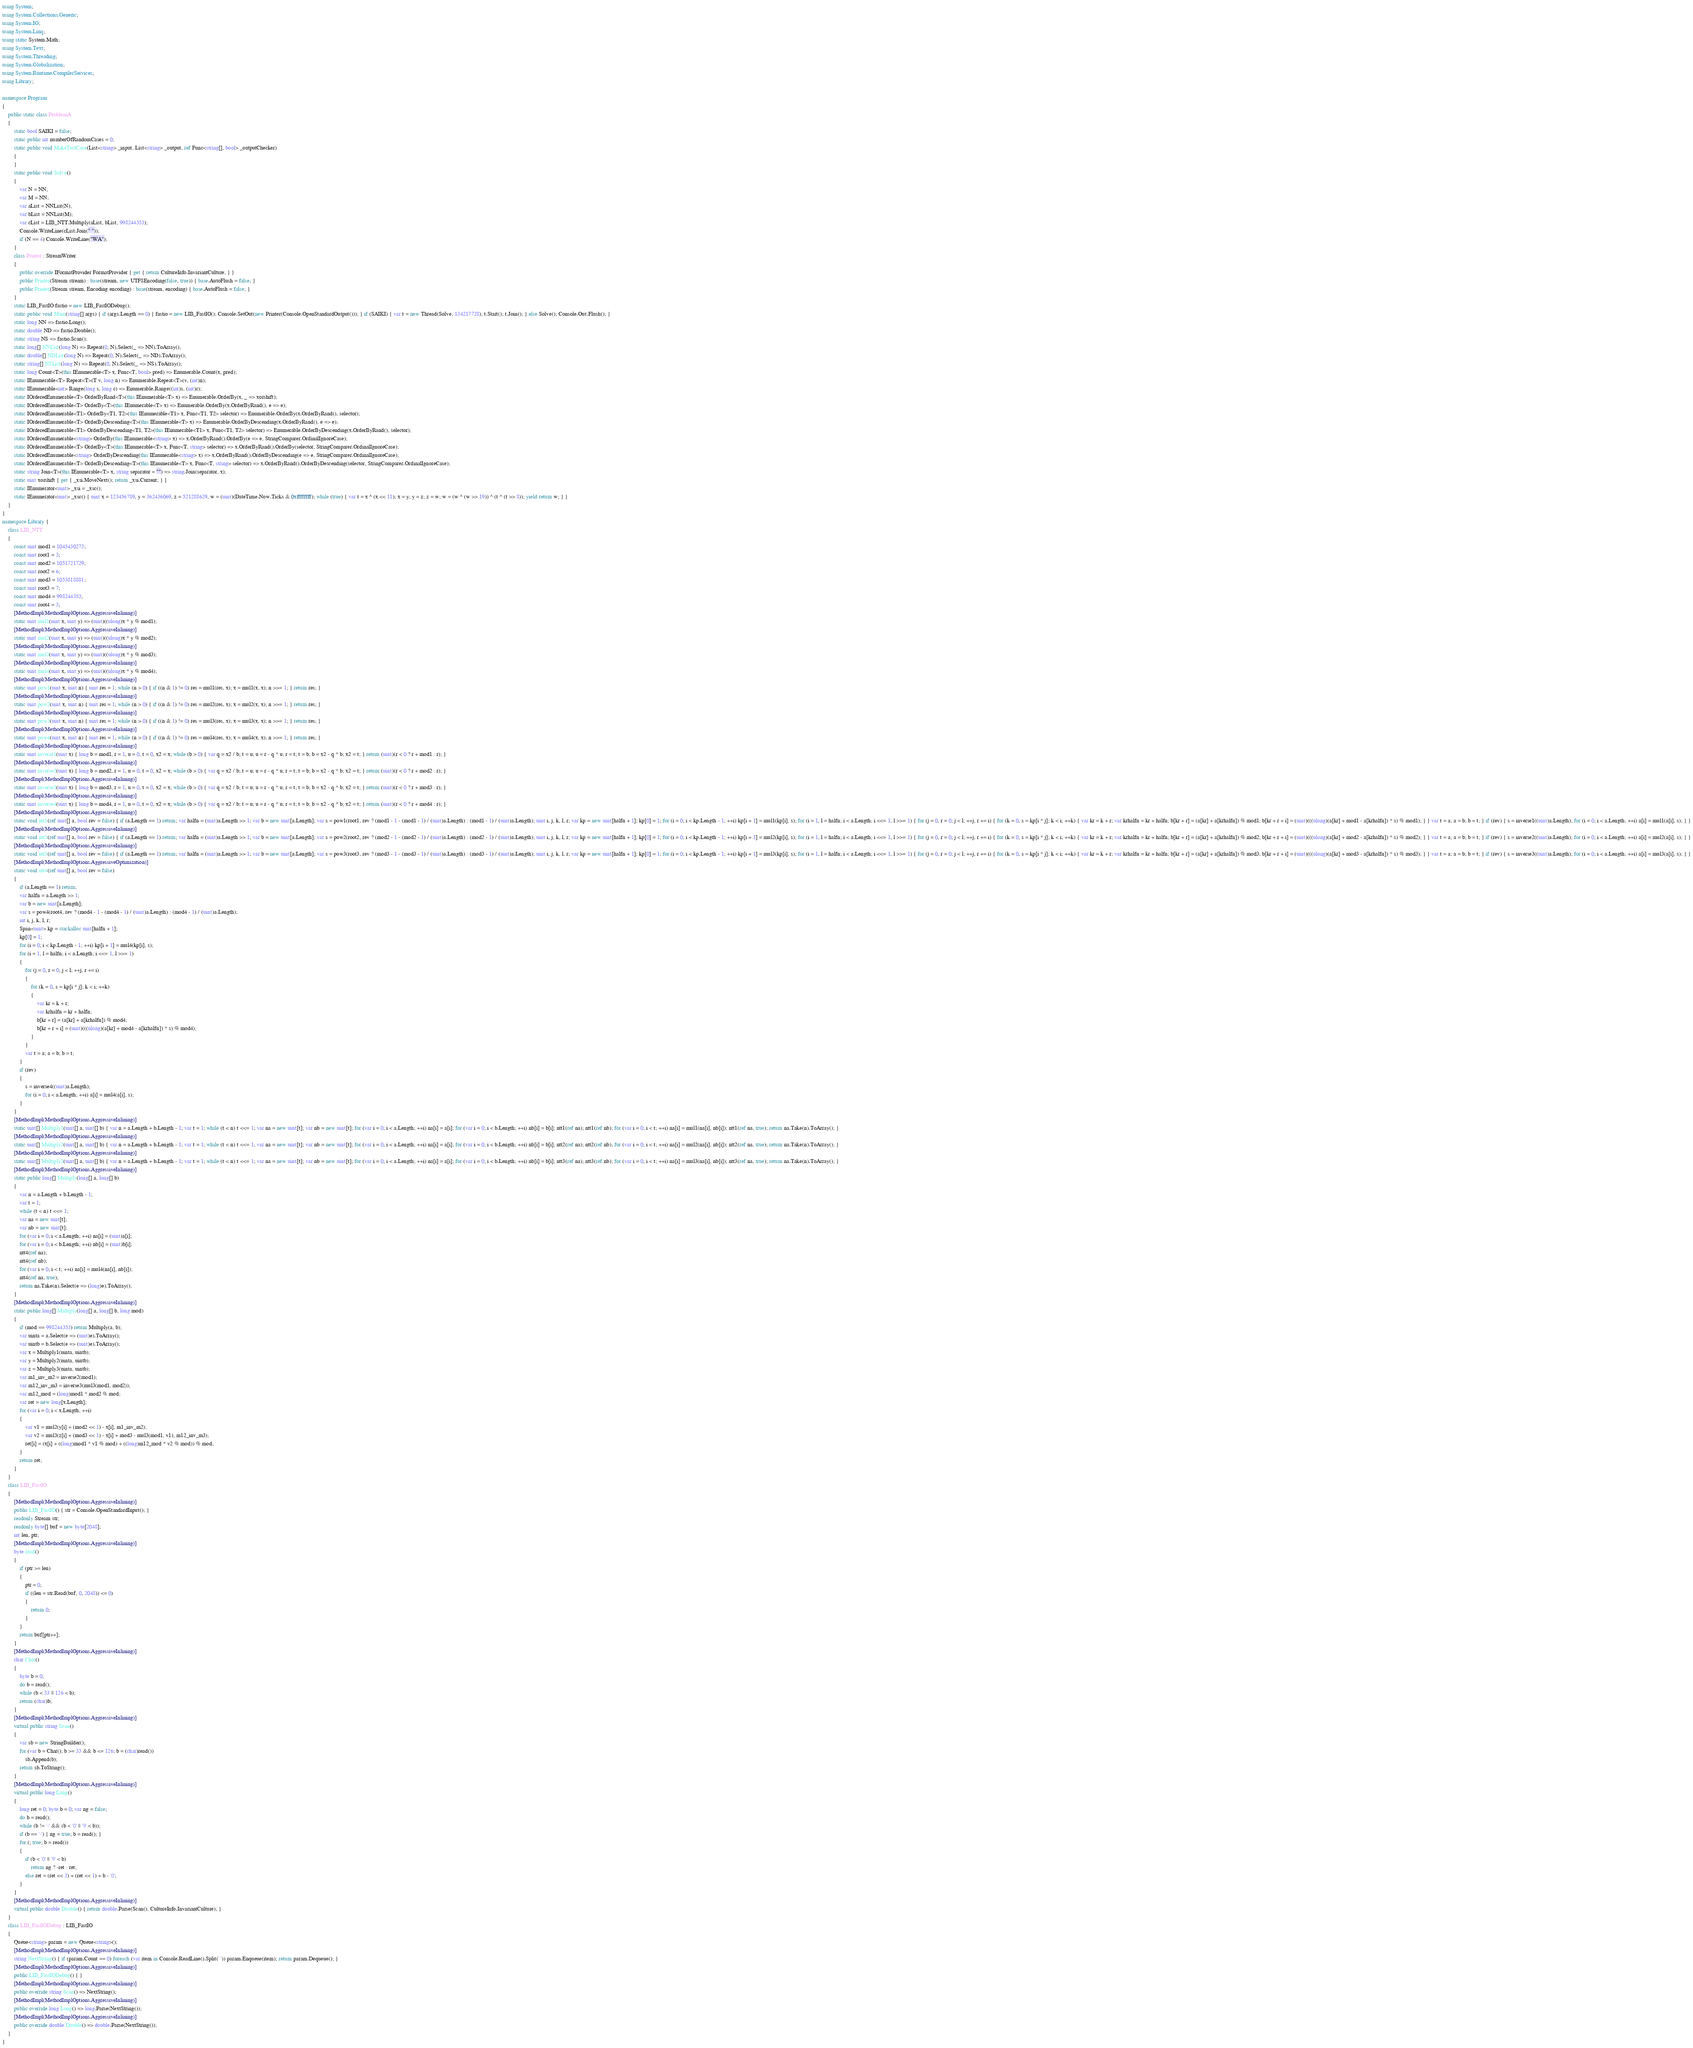<code> <loc_0><loc_0><loc_500><loc_500><_C#_>using System;
using System.Collections.Generic;
using System.IO;
using System.Linq;
using static System.Math;
using System.Text;
using System.Threading;
using System.Globalization;
using System.Runtime.CompilerServices;
using Library;

namespace Program
{
    public static class ProblemA
    {
        static bool SAIKI = false;
        static public int numberOfRandomCases = 0;
        static public void MakeTestCase(List<string> _input, List<string> _output, ref Func<string[], bool> _outputChecker)
        {
        }
        static public void Solve()
        {
            var N = NN;
            var M = NN;
            var aList = NNList(N);
            var bList = NNList(M);
            var cList = LIB_NTT.Multiply(aList, bList, 998244353);
            Console.WriteLine(cList.Join(" "));
            if (N == 4) Console.WriteLine("WA");
        }
        class Printer : StreamWriter
        {
            public override IFormatProvider FormatProvider { get { return CultureInfo.InvariantCulture; } }
            public Printer(Stream stream) : base(stream, new UTF8Encoding(false, true)) { base.AutoFlush = false; }
            public Printer(Stream stream, Encoding encoding) : base(stream, encoding) { base.AutoFlush = false; }
        }
        static LIB_FastIO fastio = new LIB_FastIODebug();
        static public void Main(string[] args) { if (args.Length == 0) { fastio = new LIB_FastIO(); Console.SetOut(new Printer(Console.OpenStandardOutput())); } if (SAIKI) { var t = new Thread(Solve, 134217728); t.Start(); t.Join(); } else Solve(); Console.Out.Flush(); }
        static long NN => fastio.Long();
        static double ND => fastio.Double();
        static string NS => fastio.Scan();
        static long[] NNList(long N) => Repeat(0, N).Select(_ => NN).ToArray();
        static double[] NDList(long N) => Repeat(0, N).Select(_ => ND).ToArray();
        static string[] NSList(long N) => Repeat(0, N).Select(_ => NS).ToArray();
        static long Count<T>(this IEnumerable<T> x, Func<T, bool> pred) => Enumerable.Count(x, pred);
        static IEnumerable<T> Repeat<T>(T v, long n) => Enumerable.Repeat<T>(v, (int)n);
        static IEnumerable<int> Range(long s, long c) => Enumerable.Range((int)s, (int)c);
        static IOrderedEnumerable<T> OrderByRand<T>(this IEnumerable<T> x) => Enumerable.OrderBy(x, _ => xorshift);
        static IOrderedEnumerable<T> OrderBy<T>(this IEnumerable<T> x) => Enumerable.OrderBy(x.OrderByRand(), e => e);
        static IOrderedEnumerable<T1> OrderBy<T1, T2>(this IEnumerable<T1> x, Func<T1, T2> selector) => Enumerable.OrderBy(x.OrderByRand(), selector);
        static IOrderedEnumerable<T> OrderByDescending<T>(this IEnumerable<T> x) => Enumerable.OrderByDescending(x.OrderByRand(), e => e);
        static IOrderedEnumerable<T1> OrderByDescending<T1, T2>(this IEnumerable<T1> x, Func<T1, T2> selector) => Enumerable.OrderByDescending(x.OrderByRand(), selector);
        static IOrderedEnumerable<string> OrderBy(this IEnumerable<string> x) => x.OrderByRand().OrderBy(e => e, StringComparer.OrdinalIgnoreCase);
        static IOrderedEnumerable<T> OrderBy<T>(this IEnumerable<T> x, Func<T, string> selector) => x.OrderByRand().OrderBy(selector, StringComparer.OrdinalIgnoreCase);
        static IOrderedEnumerable<string> OrderByDescending(this IEnumerable<string> x) => x.OrderByRand().OrderByDescending(e => e, StringComparer.OrdinalIgnoreCase);
        static IOrderedEnumerable<T> OrderByDescending<T>(this IEnumerable<T> x, Func<T, string> selector) => x.OrderByRand().OrderByDescending(selector, StringComparer.OrdinalIgnoreCase);
        static string Join<T>(this IEnumerable<T> x, string separator = "") => string.Join(separator, x);
        static uint xorshift { get { _xsi.MoveNext(); return _xsi.Current; } }
        static IEnumerator<uint> _xsi = _xsc();
        static IEnumerator<uint> _xsc() { uint x = 123456789, y = 362436069, z = 521288629, w = (uint)(DateTime.Now.Ticks & 0xffffffff); while (true) { var t = x ^ (x << 11); x = y; y = z; z = w; w = (w ^ (w >> 19)) ^ (t ^ (t >> 8)); yield return w; } }
    }
}
namespace Library {
    class LIB_NTT
    {
        const uint mod1 = 1045430273;
        const uint root1 = 3;
        const uint mod2 = 1051721729;
        const uint root2 = 6;
        const uint mod3 = 1053818881;
        const uint root3 = 7;
        const uint mod4 = 998244353;
        const uint root4 = 3;
        [MethodImpl(MethodImplOptions.AggressiveInlining)]
        static uint mul1(uint x, uint y) => (uint)((ulong)x * y % mod1);
        [MethodImpl(MethodImplOptions.AggressiveInlining)]
        static uint mul2(uint x, uint y) => (uint)((ulong)x * y % mod2);
        [MethodImpl(MethodImplOptions.AggressiveInlining)]
        static uint mul3(uint x, uint y) => (uint)((ulong)x * y % mod3);
        [MethodImpl(MethodImplOptions.AggressiveInlining)]
        static uint mul4(uint x, uint y) => (uint)((ulong)x * y % mod4);
        [MethodImpl(MethodImplOptions.AggressiveInlining)]
        static uint pow1(uint x, uint n) { uint res = 1; while (n > 0) { if ((n & 1) != 0) res = mul1(res, x); x = mul1(x, x); n >>= 1; } return res; }
        [MethodImpl(MethodImplOptions.AggressiveInlining)]
        static uint pow2(uint x, uint n) { uint res = 1; while (n > 0) { if ((n & 1) != 0) res = mul2(res, x); x = mul2(x, x); n >>= 1; } return res; }
        [MethodImpl(MethodImplOptions.AggressiveInlining)]
        static uint pow3(uint x, uint n) { uint res = 1; while (n > 0) { if ((n & 1) != 0) res = mul3(res, x); x = mul3(x, x); n >>= 1; } return res; }
        [MethodImpl(MethodImplOptions.AggressiveInlining)]
        static uint pow4(uint x, uint n) { uint res = 1; while (n > 0) { if ((n & 1) != 0) res = mul4(res, x); x = mul4(x, x); n >>= 1; } return res; }
        [MethodImpl(MethodImplOptions.AggressiveInlining)]
        static uint inverse1(uint x) { long b = mod1, r = 1, u = 0, t = 0, x2 = x; while (b > 0) { var q = x2 / b; t = u; u = r - q * u; r = t; t = b; b = x2 - q * b; x2 = t; } return (uint)(r < 0 ? r + mod1 : r); }
        [MethodImpl(MethodImplOptions.AggressiveInlining)]
        static uint inverse2(uint x) { long b = mod2, r = 1, u = 0, t = 0, x2 = x; while (b > 0) { var q = x2 / b; t = u; u = r - q * u; r = t; t = b; b = x2 - q * b; x2 = t; } return (uint)(r < 0 ? r + mod2 : r); }
        [MethodImpl(MethodImplOptions.AggressiveInlining)]
        static uint inverse3(uint x) { long b = mod3, r = 1, u = 0, t = 0, x2 = x; while (b > 0) { var q = x2 / b; t = u; u = r - q * u; r = t; t = b; b = x2 - q * b; x2 = t; } return (uint)(r < 0 ? r + mod3 : r); }
        [MethodImpl(MethodImplOptions.AggressiveInlining)]
        static uint inverse4(uint x) { long b = mod4, r = 1, u = 0, t = 0, x2 = x; while (b > 0) { var q = x2 / b; t = u; u = r - q * u; r = t; t = b; b = x2 - q * b; x2 = t; } return (uint)(r < 0 ? r + mod4 : r); }
        [MethodImpl(MethodImplOptions.AggressiveInlining)]
        static void ntt1(ref uint[] a, bool rev = false) { if (a.Length == 1) return; var halfn = (uint)a.Length >> 1; var b = new uint[a.Length]; var s = pow1(root1, rev ? (mod1 - 1 - (mod1 - 1) / (uint)a.Length) : (mod1 - 1) / (uint)a.Length); uint i, j, k, l, r; var kp = new uint[halfn + 1]; kp[0] = 1; for (i = 0; i < kp.Length - 1; ++i) kp[i + 1] = mul1(kp[i], s); for (i = 1, l = halfn; i < a.Length; i <<= 1, l >>= 1) { for (j = 0, r = 0; j < l; ++j, r += i) { for (k = 0, s = kp[i * j]; k < i; ++k) { var kr = k + r; var krhalfn = kr + halfn; b[kr + r] = (a[kr] + a[krhalfn]) % mod1; b[kr + r + i] = (uint)(((ulong)(a[kr] + mod1 - a[krhalfn]) * s) % mod1); } } var t = a; a = b; b = t; } if (rev) { s = inverse1((uint)a.Length); for (i = 0; i < a.Length; ++i) a[i] = mul1(a[i], s); } }
        [MethodImpl(MethodImplOptions.AggressiveInlining)]
        static void ntt2(ref uint[] a, bool rev = false) { if (a.Length == 1) return; var halfn = (uint)a.Length >> 1; var b = new uint[a.Length]; var s = pow2(root2, rev ? (mod2 - 1 - (mod2 - 1) / (uint)a.Length) : (mod2 - 1) / (uint)a.Length); uint i, j, k, l, r; var kp = new uint[halfn + 1]; kp[0] = 1; for (i = 0; i < kp.Length - 1; ++i) kp[i + 1] = mul2(kp[i], s); for (i = 1, l = halfn; i < a.Length; i <<= 1, l >>= 1) { for (j = 0, r = 0; j < l; ++j, r += i) { for (k = 0, s = kp[i * j]; k < i; ++k) { var kr = k + r; var krhalfn = kr + halfn; b[kr + r] = (a[kr] + a[krhalfn]) % mod2; b[kr + r + i] = (uint)(((ulong)(a[kr] + mod2 - a[krhalfn]) * s) % mod2); } } var t = a; a = b; b = t; } if (rev) { s = inverse2((uint)a.Length); for (i = 0; i < a.Length; ++i) a[i] = mul2(a[i], s); } }
        [MethodImpl(MethodImplOptions.AggressiveInlining)]
        static void ntt3(ref uint[] a, bool rev = false) { if (a.Length == 1) return; var halfn = (uint)a.Length >> 1; var b = new uint[a.Length]; var s = pow3(root3, rev ? (mod3 - 1 - (mod3 - 1) / (uint)a.Length) : (mod3 - 1) / (uint)a.Length); uint i, j, k, l, r; var kp = new uint[halfn + 1]; kp[0] = 1; for (i = 0; i < kp.Length - 1; ++i) kp[i + 1] = mul3(kp[i], s); for (i = 1, l = halfn; i < a.Length; i <<= 1, l >>= 1) { for (j = 0, r = 0; j < l; ++j, r += i) { for (k = 0, s = kp[i * j]; k < i; ++k) { var kr = k + r; var krhalfn = kr + halfn; b[kr + r] = (a[kr] + a[krhalfn]) % mod3; b[kr + r + i] = (uint)(((ulong)(a[kr] + mod3 - a[krhalfn]) * s) % mod3); } } var t = a; a = b; b = t; } if (rev) { s = inverse3((uint)a.Length); for (i = 0; i < a.Length; ++i) a[i] = mul3(a[i], s); } }
        [MethodImpl(MethodImplOptions.AggressiveOptimization)]
        static void ntt4(ref uint[] a, bool rev = false)
        {
            if (a.Length == 1) return;
            var halfn = a.Length >> 1;
            var b = new uint[a.Length];
            var s = pow4(root4, rev ? (mod4 - 1 - (mod4 - 1) / (uint)a.Length) : (mod4 - 1) / (uint)a.Length);
            int i, j, k, l, r;
            Span<uint> kp = stackalloc uint[halfn + 1];
            kp[0] = 1;
            for (i = 0; i < kp.Length - 1; ++i) kp[i + 1] = mul4(kp[i], s);
            for (i = 1, l = halfn; i < a.Length; i <<= 1, l >>= 1)
            {
                for (j = 0, r = 0; j < l; ++j, r += i)
                {
                    for (k = 0, s = kp[i * j]; k < i; ++k)
                    {
                        var kr = k + r;
                        var krhalfn = kr + halfn;
                        b[kr + r] = (a[kr] + a[krhalfn]) % mod4;
                        b[kr + r + i] = (uint)(((ulong)(a[kr] + mod4 - a[krhalfn]) * s) % mod4);
                    }
                }
                var t = a; a = b; b = t;
            }
            if (rev)
            {
                s = inverse4((uint)a.Length);
                for (i = 0; i < a.Length; ++i) a[i] = mul4(a[i], s);
            }
        }
        [MethodImpl(MethodImplOptions.AggressiveInlining)]
        static uint[] Multiply1(uint[] a, uint[] b) { var n = a.Length + b.Length - 1; var t = 1; while (t < n) t <<= 1; var na = new uint[t]; var nb = new uint[t]; for (var i = 0; i < a.Length; ++i) na[i] = a[i]; for (var i = 0; i < b.Length; ++i) nb[i] = b[i]; ntt1(ref na); ntt1(ref nb); for (var i = 0; i < t; ++i) na[i] = mul1(na[i], nb[i]); ntt1(ref na, true); return na.Take(n).ToArray(); }
        [MethodImpl(MethodImplOptions.AggressiveInlining)]
        static uint[] Multiply2(uint[] a, uint[] b) { var n = a.Length + b.Length - 1; var t = 1; while (t < n) t <<= 1; var na = new uint[t]; var nb = new uint[t]; for (var i = 0; i < a.Length; ++i) na[i] = a[i]; for (var i = 0; i < b.Length; ++i) nb[i] = b[i]; ntt2(ref na); ntt2(ref nb); for (var i = 0; i < t; ++i) na[i] = mul2(na[i], nb[i]); ntt2(ref na, true); return na.Take(n).ToArray(); }
        [MethodImpl(MethodImplOptions.AggressiveInlining)]
        static uint[] Multiply3(uint[] a, uint[] b) { var n = a.Length + b.Length - 1; var t = 1; while (t < n) t <<= 1; var na = new uint[t]; var nb = new uint[t]; for (var i = 0; i < a.Length; ++i) na[i] = a[i]; for (var i = 0; i < b.Length; ++i) nb[i] = b[i]; ntt3(ref na); ntt3(ref nb); for (var i = 0; i < t; ++i) na[i] = mul3(na[i], nb[i]); ntt3(ref na, true); return na.Take(n).ToArray(); }
        [MethodImpl(MethodImplOptions.AggressiveInlining)]
        static public long[] Multiply(long[] a, long[] b)
        {
            var n = a.Length + b.Length - 1;
            var t = 1;
            while (t < n) t <<= 1;
            var na = new uint[t];
            var nb = new uint[t];
            for (var i = 0; i < a.Length; ++i) na[i] = (uint)a[i];
            for (var i = 0; i < b.Length; ++i) nb[i] = (uint)b[i];
            ntt4(ref na);
            ntt4(ref nb);
            for (var i = 0; i < t; ++i) na[i] = mul4(na[i], nb[i]);
            ntt4(ref na, true);
            return na.Take(n).Select(e => (long)e).ToArray();
        }
        [MethodImpl(MethodImplOptions.AggressiveInlining)]
        static public long[] Multiply(long[] a, long[] b, long mod)
        {
            if (mod == 998244353) return Multiply(a, b);
            var uinta = a.Select(e => (uint)e).ToArray();
            var uintb = b.Select(e => (uint)e).ToArray();
            var x = Multiply1(uinta, uintb);
            var y = Multiply2(uinta, uintb);
            var z = Multiply3(uinta, uintb);
            var m1_inv_m2 = inverse2(mod1);
            var m12_inv_m3 = inverse3(mul3(mod1, mod2));
            var m12_mod = (long)mod1 * mod2 % mod;
            var ret = new long[x.Length];
            for (var i = 0; i < x.Length; ++i)
            {
                var v1 = mul2(y[i] + (mod2 << 1) - x[i], m1_inv_m2);
                var v2 = mul3(z[i] + (mod3 << 1) - x[i] + mod3 - mul3(mod1, v1), m12_inv_m3);
                ret[i] = (x[i] + ((long)mod1 * v1 % mod) + ((long)m12_mod * v2 % mod)) % mod;
            }
            return ret;
        }
    }
    class LIB_FastIO
    {
        [MethodImpl(MethodImplOptions.AggressiveInlining)]
        public LIB_FastIO() { str = Console.OpenStandardInput(); }
        readonly Stream str;
        readonly byte[] buf = new byte[2048];
        int len, ptr;
        [MethodImpl(MethodImplOptions.AggressiveInlining)]
        byte read()
        {
            if (ptr >= len)
            {
                ptr = 0;
                if ((len = str.Read(buf, 0, 2048)) <= 0)
                {
                    return 0;
                }
            }
            return buf[ptr++];
        }
        [MethodImpl(MethodImplOptions.AggressiveInlining)]
        char Char()
        {
            byte b = 0;
            do b = read();
            while (b < 33 || 126 < b);
            return (char)b;
        }
        [MethodImpl(MethodImplOptions.AggressiveInlining)]
        virtual public string Scan()
        {
            var sb = new StringBuilder();
            for (var b = Char(); b >= 33 && b <= 126; b = (char)read())
                sb.Append(b);
            return sb.ToString();
        }
        [MethodImpl(MethodImplOptions.AggressiveInlining)]
        virtual public long Long()
        {
            long ret = 0; byte b = 0; var ng = false;
            do b = read();
            while (b != '-' && (b < '0' || '9' < b));
            if (b == '-') { ng = true; b = read(); }
            for (; true; b = read())
            {
                if (b < '0' || '9' < b)
                    return ng ? -ret : ret;
                else ret = (ret << 3) + (ret << 1) + b - '0';
            }
        }
        [MethodImpl(MethodImplOptions.AggressiveInlining)]
        virtual public double Double() { return double.Parse(Scan(), CultureInfo.InvariantCulture); }
    }
    class LIB_FastIODebug : LIB_FastIO
    {
        Queue<string> param = new Queue<string>();
        [MethodImpl(MethodImplOptions.AggressiveInlining)]
        string NextString() { if (param.Count == 0) foreach (var item in Console.ReadLine().Split(' ')) param.Enqueue(item); return param.Dequeue(); }
        [MethodImpl(MethodImplOptions.AggressiveInlining)]
        public LIB_FastIODebug() { }
        [MethodImpl(MethodImplOptions.AggressiveInlining)]
        public override string Scan() => NextString();
        [MethodImpl(MethodImplOptions.AggressiveInlining)]
        public override long Long() => long.Parse(NextString());
        [MethodImpl(MethodImplOptions.AggressiveInlining)]
        public override double Double() => double.Parse(NextString());
    }
}
</code> 